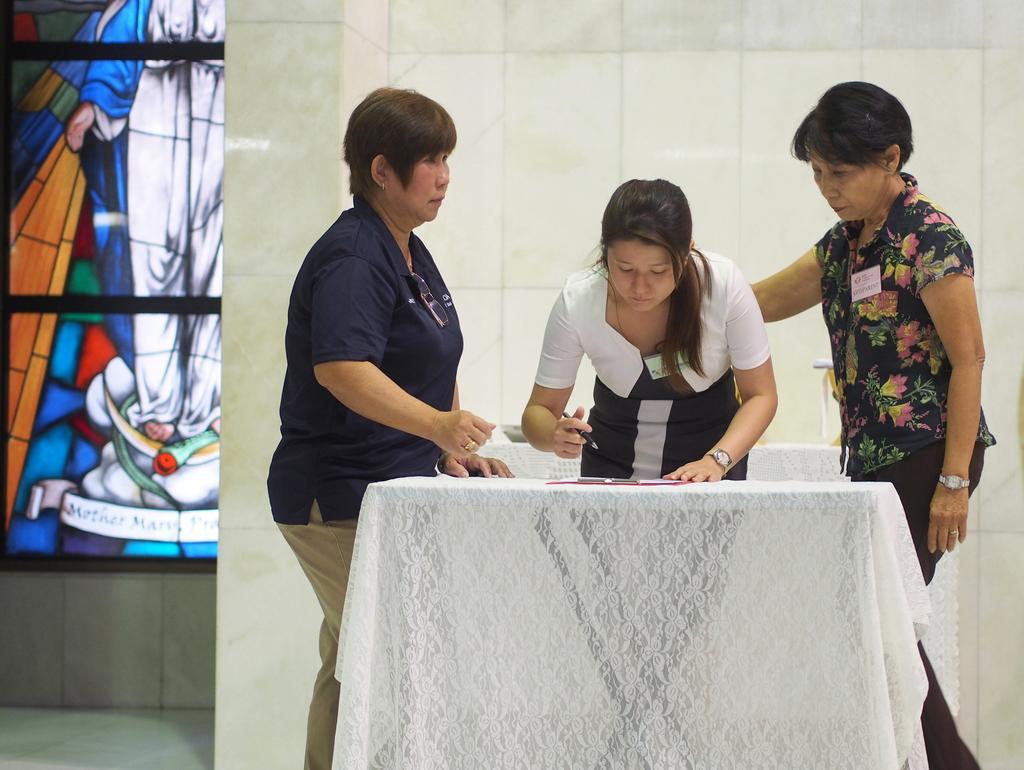Please provide a concise description of this image. This picture is taken inside the room. In this image, on the right side, we can see three people are standing in front of the table. On the table, we can see a white colored cloth and a book. On the left side, we can see a glass window with some paintings. In the background, we can see a table with white color cloth and a bowl. In the background, we can also see a wall which is in white color. 